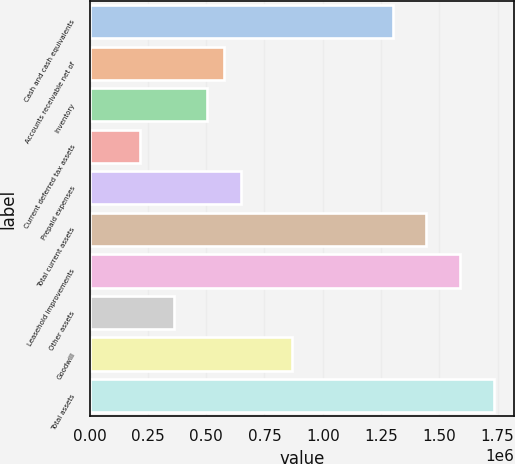Convert chart to OTSL. <chart><loc_0><loc_0><loc_500><loc_500><bar_chart><fcel>Cash and cash equivalents<fcel>Accounts receivable net of<fcel>Inventory<fcel>Current deferred tax assets<fcel>Prepaid expenses<fcel>Total current assets<fcel>Leasehold improvements<fcel>Other assets<fcel>Goodwill<fcel>Total assets<nl><fcel>1.29975e+06<fcel>577707<fcel>505503<fcel>216688<fcel>649911<fcel>1.44415e+06<fcel>1.58856e+06<fcel>361096<fcel>866523<fcel>1.73297e+06<nl></chart> 